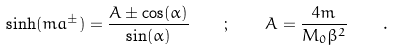<formula> <loc_0><loc_0><loc_500><loc_500>\sinh ( m a ^ { \pm } ) = \frac { A \pm \cos ( \alpha ) } { \sin ( \alpha ) } \quad ; \quad A = \frac { 4 m } { M _ { 0 } \beta ^ { 2 } } \quad .</formula> 